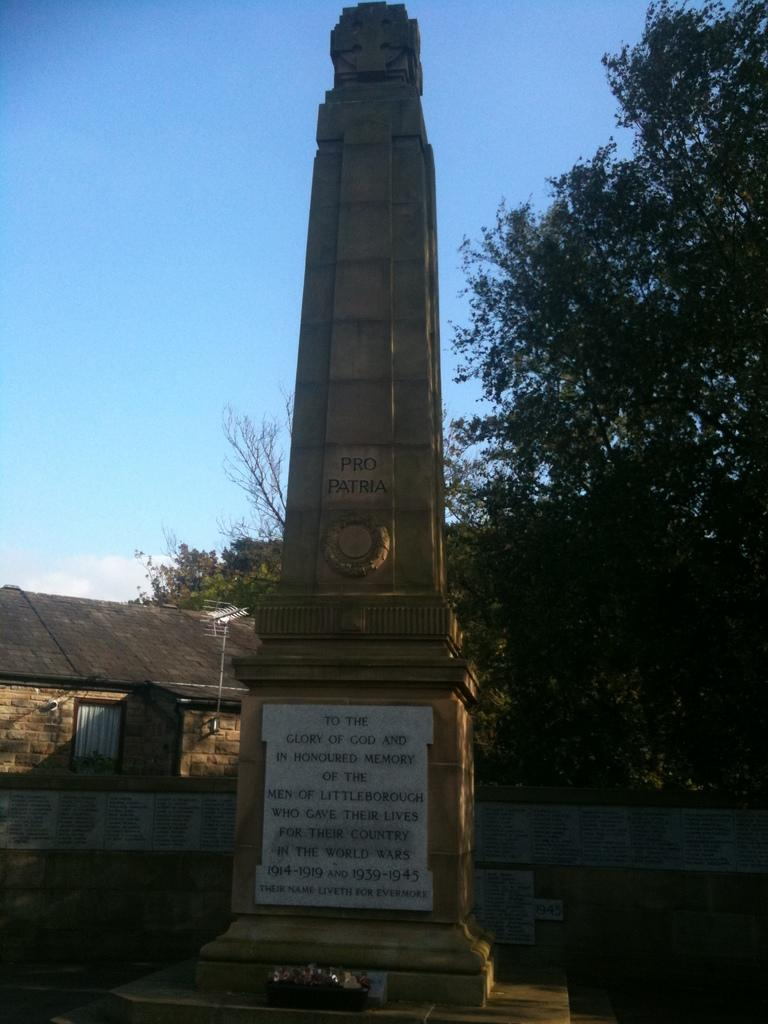What type of setting is depicted in the image? The image is an outside view. What is the main object in the image? There is a memorial stone in the image. What can be read on the memorial stone? Text is visible on the memorial stone. What can be seen in the background of the image? There are trees and a house in the background of the image. What is visible at the top of the image? The sky is visible at the top of the image. How many pieces of lace can be seen hanging from the trees in the image? There is no lace visible in the image; it only features a memorial stone, trees, a house, and the sky. What type of drink is being offered by the deer in the image? There are no deer present in the image, and therefore no drinks are being offered. 